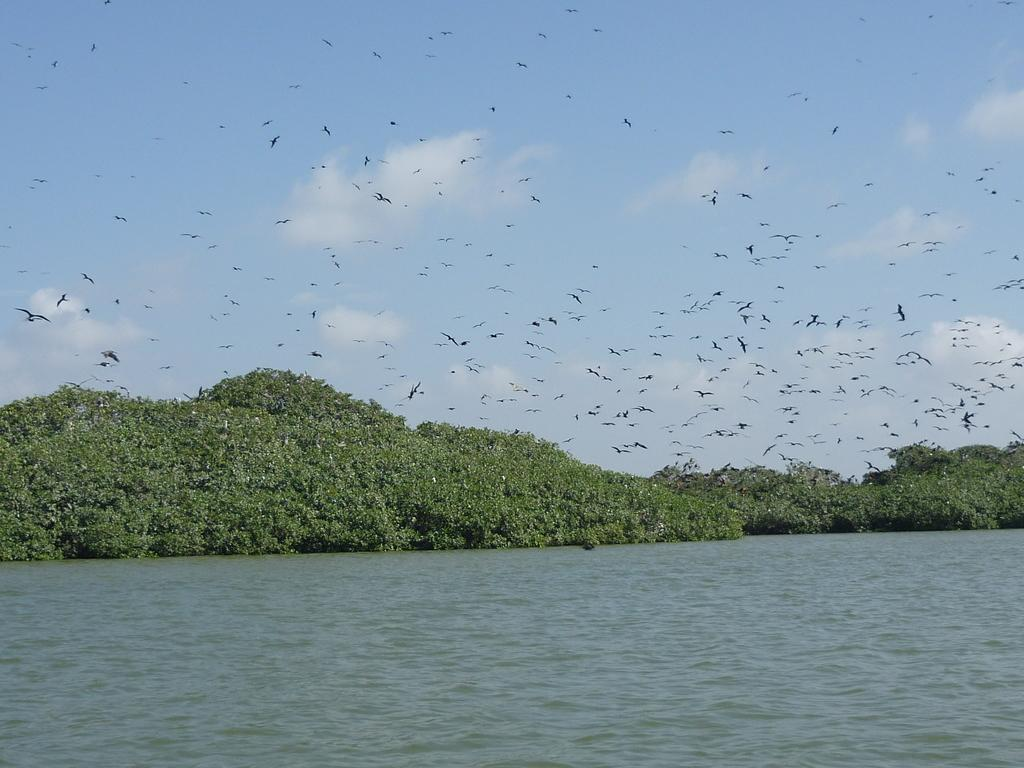What is one of the natural elements present in the image? There is water in the image. What type of vegetation can be seen in the image? There are trees in the image. What animals are visible in the image? Birds are flying in the image. How would you describe the sky in the image? The sky is blue and cloudy. What type of toothbrush is being used by the birds in the image? There is no toothbrush present in the image, and birds do not use toothbrushes. What hobbies do the trees in the image enjoy? Trees do not have hobbies, as they are inanimate objects. 